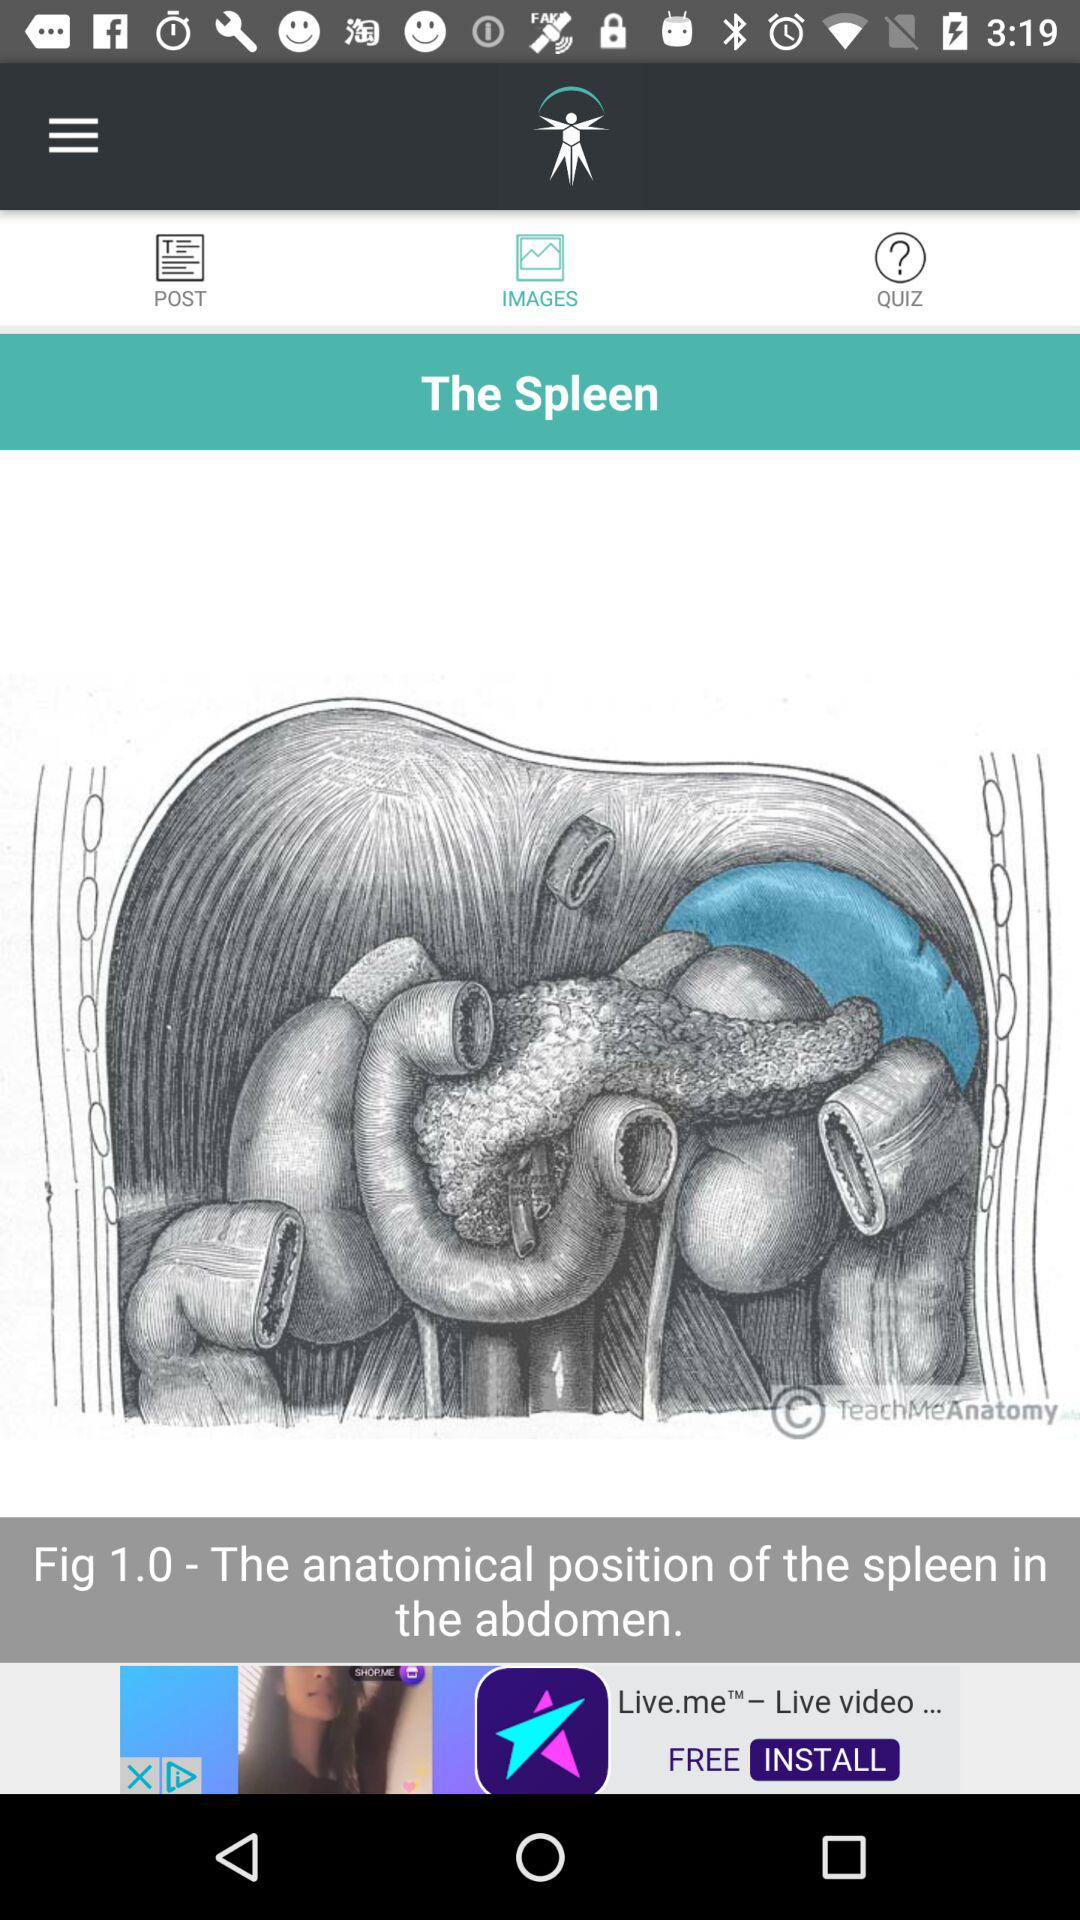Which tab has been selected? The tab that has been selected is "IMAGES". 